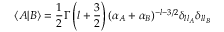Convert formula to latex. <formula><loc_0><loc_0><loc_500><loc_500>\langle A | B \rangle = \frac { 1 } { 2 } \Gamma \left ( l + \frac { 3 } { 2 } \right ) ( \alpha _ { A } + \alpha _ { B } ) ^ { - l - 3 / 2 } \delta _ { l l _ { A } } \delta _ { l l _ { B } }</formula> 